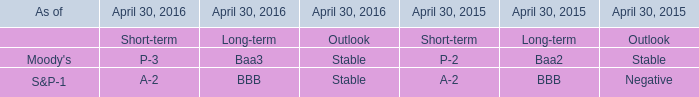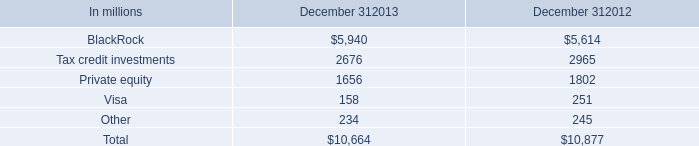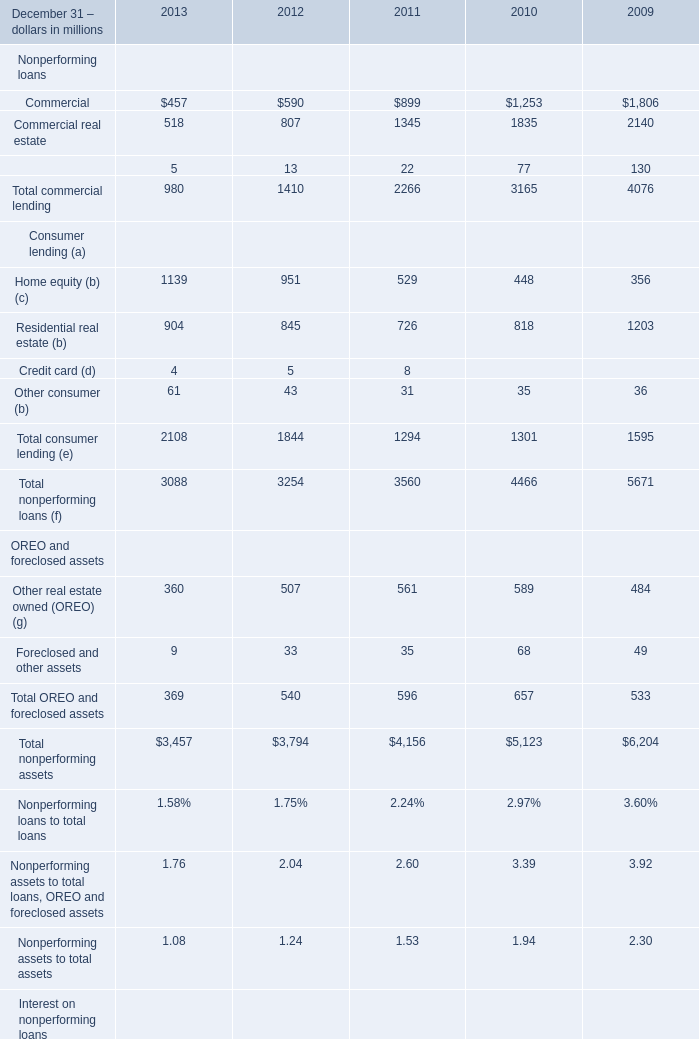What is the sum of commercial lending in the range of 500 and 2000 in 2011? (in million) 
Computations: (899 + 1345)
Answer: 2244.0. 